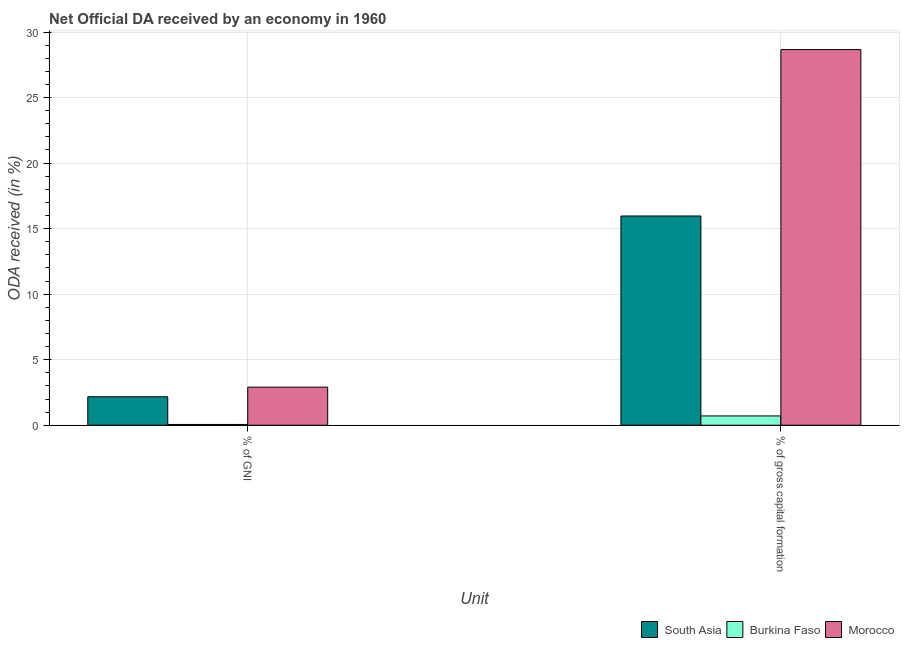How many different coloured bars are there?
Offer a very short reply. 3. How many groups of bars are there?
Give a very brief answer. 2. Are the number of bars per tick equal to the number of legend labels?
Give a very brief answer. Yes. Are the number of bars on each tick of the X-axis equal?
Keep it short and to the point. Yes. How many bars are there on the 2nd tick from the right?
Your response must be concise. 3. What is the label of the 1st group of bars from the left?
Your answer should be very brief. % of GNI. What is the oda received as percentage of gross capital formation in South Asia?
Provide a succinct answer. 15.96. Across all countries, what is the maximum oda received as percentage of gross capital formation?
Your answer should be very brief. 28.66. Across all countries, what is the minimum oda received as percentage of gross capital formation?
Offer a very short reply. 0.71. In which country was the oda received as percentage of gni maximum?
Provide a succinct answer. Morocco. In which country was the oda received as percentage of gni minimum?
Offer a terse response. Burkina Faso. What is the total oda received as percentage of gross capital formation in the graph?
Provide a succinct answer. 45.33. What is the difference between the oda received as percentage of gross capital formation in Burkina Faso and that in South Asia?
Provide a succinct answer. -15.25. What is the difference between the oda received as percentage of gross capital formation in South Asia and the oda received as percentage of gni in Morocco?
Offer a very short reply. 13.06. What is the average oda received as percentage of gni per country?
Keep it short and to the point. 1.71. What is the difference between the oda received as percentage of gni and oda received as percentage of gross capital formation in Burkina Faso?
Your answer should be compact. -0.65. What is the ratio of the oda received as percentage of gross capital formation in South Asia to that in Morocco?
Provide a succinct answer. 0.56. What does the 3rd bar from the left in % of GNI represents?
Your answer should be compact. Morocco. What does the 1st bar from the right in % of GNI represents?
Keep it short and to the point. Morocco. How many bars are there?
Give a very brief answer. 6. Are all the bars in the graph horizontal?
Ensure brevity in your answer.  No. Are the values on the major ticks of Y-axis written in scientific E-notation?
Your answer should be compact. No. Where does the legend appear in the graph?
Provide a short and direct response. Bottom right. How many legend labels are there?
Make the answer very short. 3. What is the title of the graph?
Make the answer very short. Net Official DA received by an economy in 1960. What is the label or title of the X-axis?
Make the answer very short. Unit. What is the label or title of the Y-axis?
Ensure brevity in your answer.  ODA received (in %). What is the ODA received (in %) of South Asia in % of GNI?
Offer a terse response. 2.17. What is the ODA received (in %) in Burkina Faso in % of GNI?
Your response must be concise. 0.06. What is the ODA received (in %) in Morocco in % of GNI?
Offer a very short reply. 2.91. What is the ODA received (in %) of South Asia in % of gross capital formation?
Your response must be concise. 15.96. What is the ODA received (in %) of Burkina Faso in % of gross capital formation?
Your response must be concise. 0.71. What is the ODA received (in %) of Morocco in % of gross capital formation?
Offer a very short reply. 28.66. Across all Unit, what is the maximum ODA received (in %) of South Asia?
Ensure brevity in your answer.  15.96. Across all Unit, what is the maximum ODA received (in %) in Burkina Faso?
Your response must be concise. 0.71. Across all Unit, what is the maximum ODA received (in %) in Morocco?
Give a very brief answer. 28.66. Across all Unit, what is the minimum ODA received (in %) of South Asia?
Keep it short and to the point. 2.17. Across all Unit, what is the minimum ODA received (in %) in Burkina Faso?
Provide a succinct answer. 0.06. Across all Unit, what is the minimum ODA received (in %) in Morocco?
Provide a succinct answer. 2.91. What is the total ODA received (in %) in South Asia in the graph?
Provide a short and direct response. 18.14. What is the total ODA received (in %) of Burkina Faso in the graph?
Make the answer very short. 0.77. What is the total ODA received (in %) in Morocco in the graph?
Provide a short and direct response. 31.56. What is the difference between the ODA received (in %) in South Asia in % of GNI and that in % of gross capital formation?
Keep it short and to the point. -13.79. What is the difference between the ODA received (in %) in Burkina Faso in % of GNI and that in % of gross capital formation?
Provide a short and direct response. -0.65. What is the difference between the ODA received (in %) in Morocco in % of GNI and that in % of gross capital formation?
Keep it short and to the point. -25.75. What is the difference between the ODA received (in %) in South Asia in % of GNI and the ODA received (in %) in Burkina Faso in % of gross capital formation?
Offer a very short reply. 1.46. What is the difference between the ODA received (in %) of South Asia in % of GNI and the ODA received (in %) of Morocco in % of gross capital formation?
Offer a terse response. -26.48. What is the difference between the ODA received (in %) of Burkina Faso in % of GNI and the ODA received (in %) of Morocco in % of gross capital formation?
Keep it short and to the point. -28.6. What is the average ODA received (in %) of South Asia per Unit?
Offer a very short reply. 9.07. What is the average ODA received (in %) of Burkina Faso per Unit?
Give a very brief answer. 0.39. What is the average ODA received (in %) of Morocco per Unit?
Ensure brevity in your answer.  15.78. What is the difference between the ODA received (in %) in South Asia and ODA received (in %) in Burkina Faso in % of GNI?
Provide a short and direct response. 2.11. What is the difference between the ODA received (in %) of South Asia and ODA received (in %) of Morocco in % of GNI?
Offer a terse response. -0.74. What is the difference between the ODA received (in %) in Burkina Faso and ODA received (in %) in Morocco in % of GNI?
Offer a very short reply. -2.85. What is the difference between the ODA received (in %) in South Asia and ODA received (in %) in Burkina Faso in % of gross capital formation?
Provide a succinct answer. 15.25. What is the difference between the ODA received (in %) in South Asia and ODA received (in %) in Morocco in % of gross capital formation?
Your answer should be very brief. -12.69. What is the difference between the ODA received (in %) in Burkina Faso and ODA received (in %) in Morocco in % of gross capital formation?
Your response must be concise. -27.95. What is the ratio of the ODA received (in %) in South Asia in % of GNI to that in % of gross capital formation?
Your response must be concise. 0.14. What is the ratio of the ODA received (in %) of Burkina Faso in % of GNI to that in % of gross capital formation?
Provide a succinct answer. 0.08. What is the ratio of the ODA received (in %) in Morocco in % of GNI to that in % of gross capital formation?
Your answer should be very brief. 0.1. What is the difference between the highest and the second highest ODA received (in %) of South Asia?
Give a very brief answer. 13.79. What is the difference between the highest and the second highest ODA received (in %) in Burkina Faso?
Offer a very short reply. 0.65. What is the difference between the highest and the second highest ODA received (in %) in Morocco?
Keep it short and to the point. 25.75. What is the difference between the highest and the lowest ODA received (in %) of South Asia?
Ensure brevity in your answer.  13.79. What is the difference between the highest and the lowest ODA received (in %) in Burkina Faso?
Keep it short and to the point. 0.65. What is the difference between the highest and the lowest ODA received (in %) of Morocco?
Your answer should be compact. 25.75. 